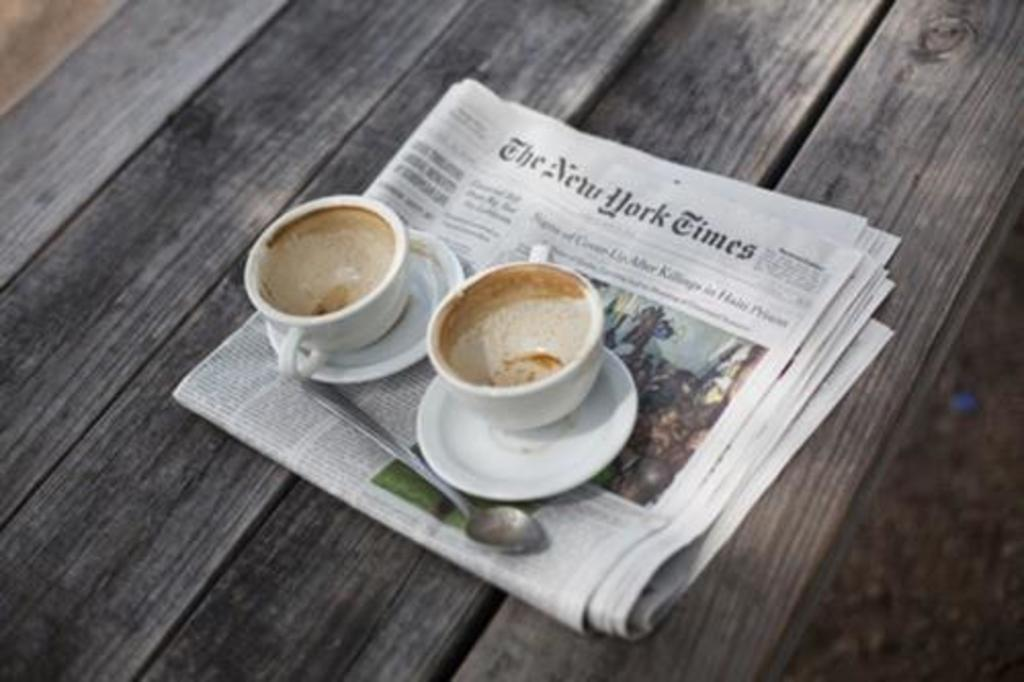What piece of furniture is present in the image? There is a table in the image. What is placed on the table? There is a newspaper on the table. What object is on top of the newspaper? There is a spoon on the newspaper. How many cups are visible in the image? There are two cups in the image. What accompanies the cups in the image? There are two saucers in the image. What type of waves can be seen crashing against the shore in the image? There are no waves or shore visible in the image; it features a table with a newspaper, spoon, cups, and saucers. 